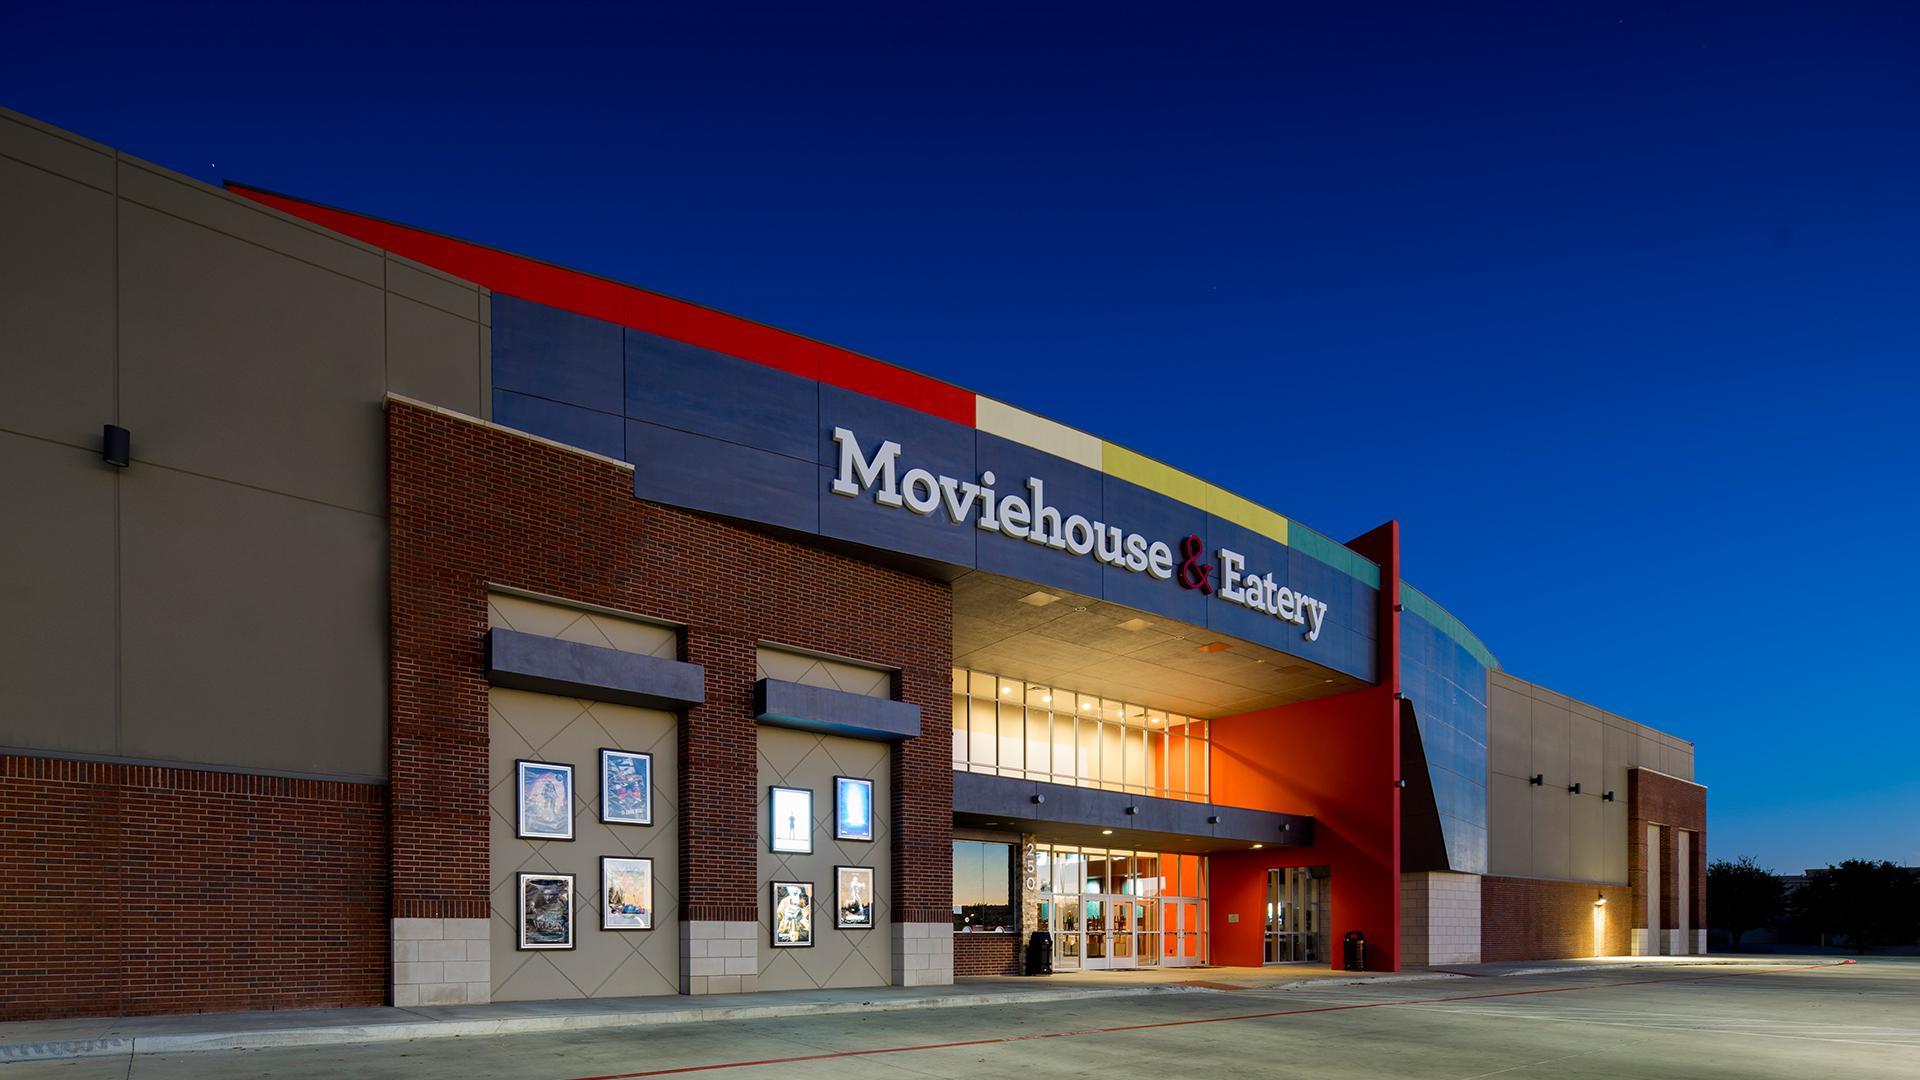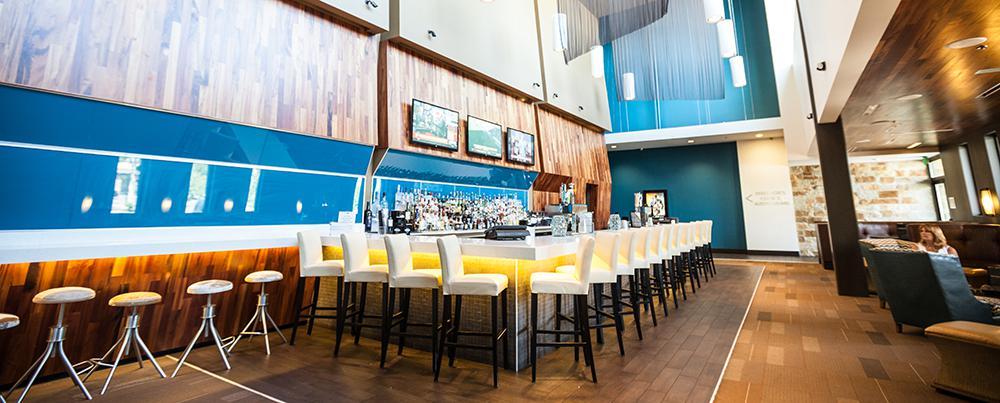The first image is the image on the left, the second image is the image on the right. For the images displayed, is the sentence "The right image shows an interior with backless stools leading to white chair-type stools at a bar with glowing yellow underlighting." factually correct? Answer yes or no. Yes. The first image is the image on the left, the second image is the image on the right. Analyze the images presented: Is the assertion "Signage hangs above the entrance of the place in the image on the right." valid? Answer yes or no. No. 